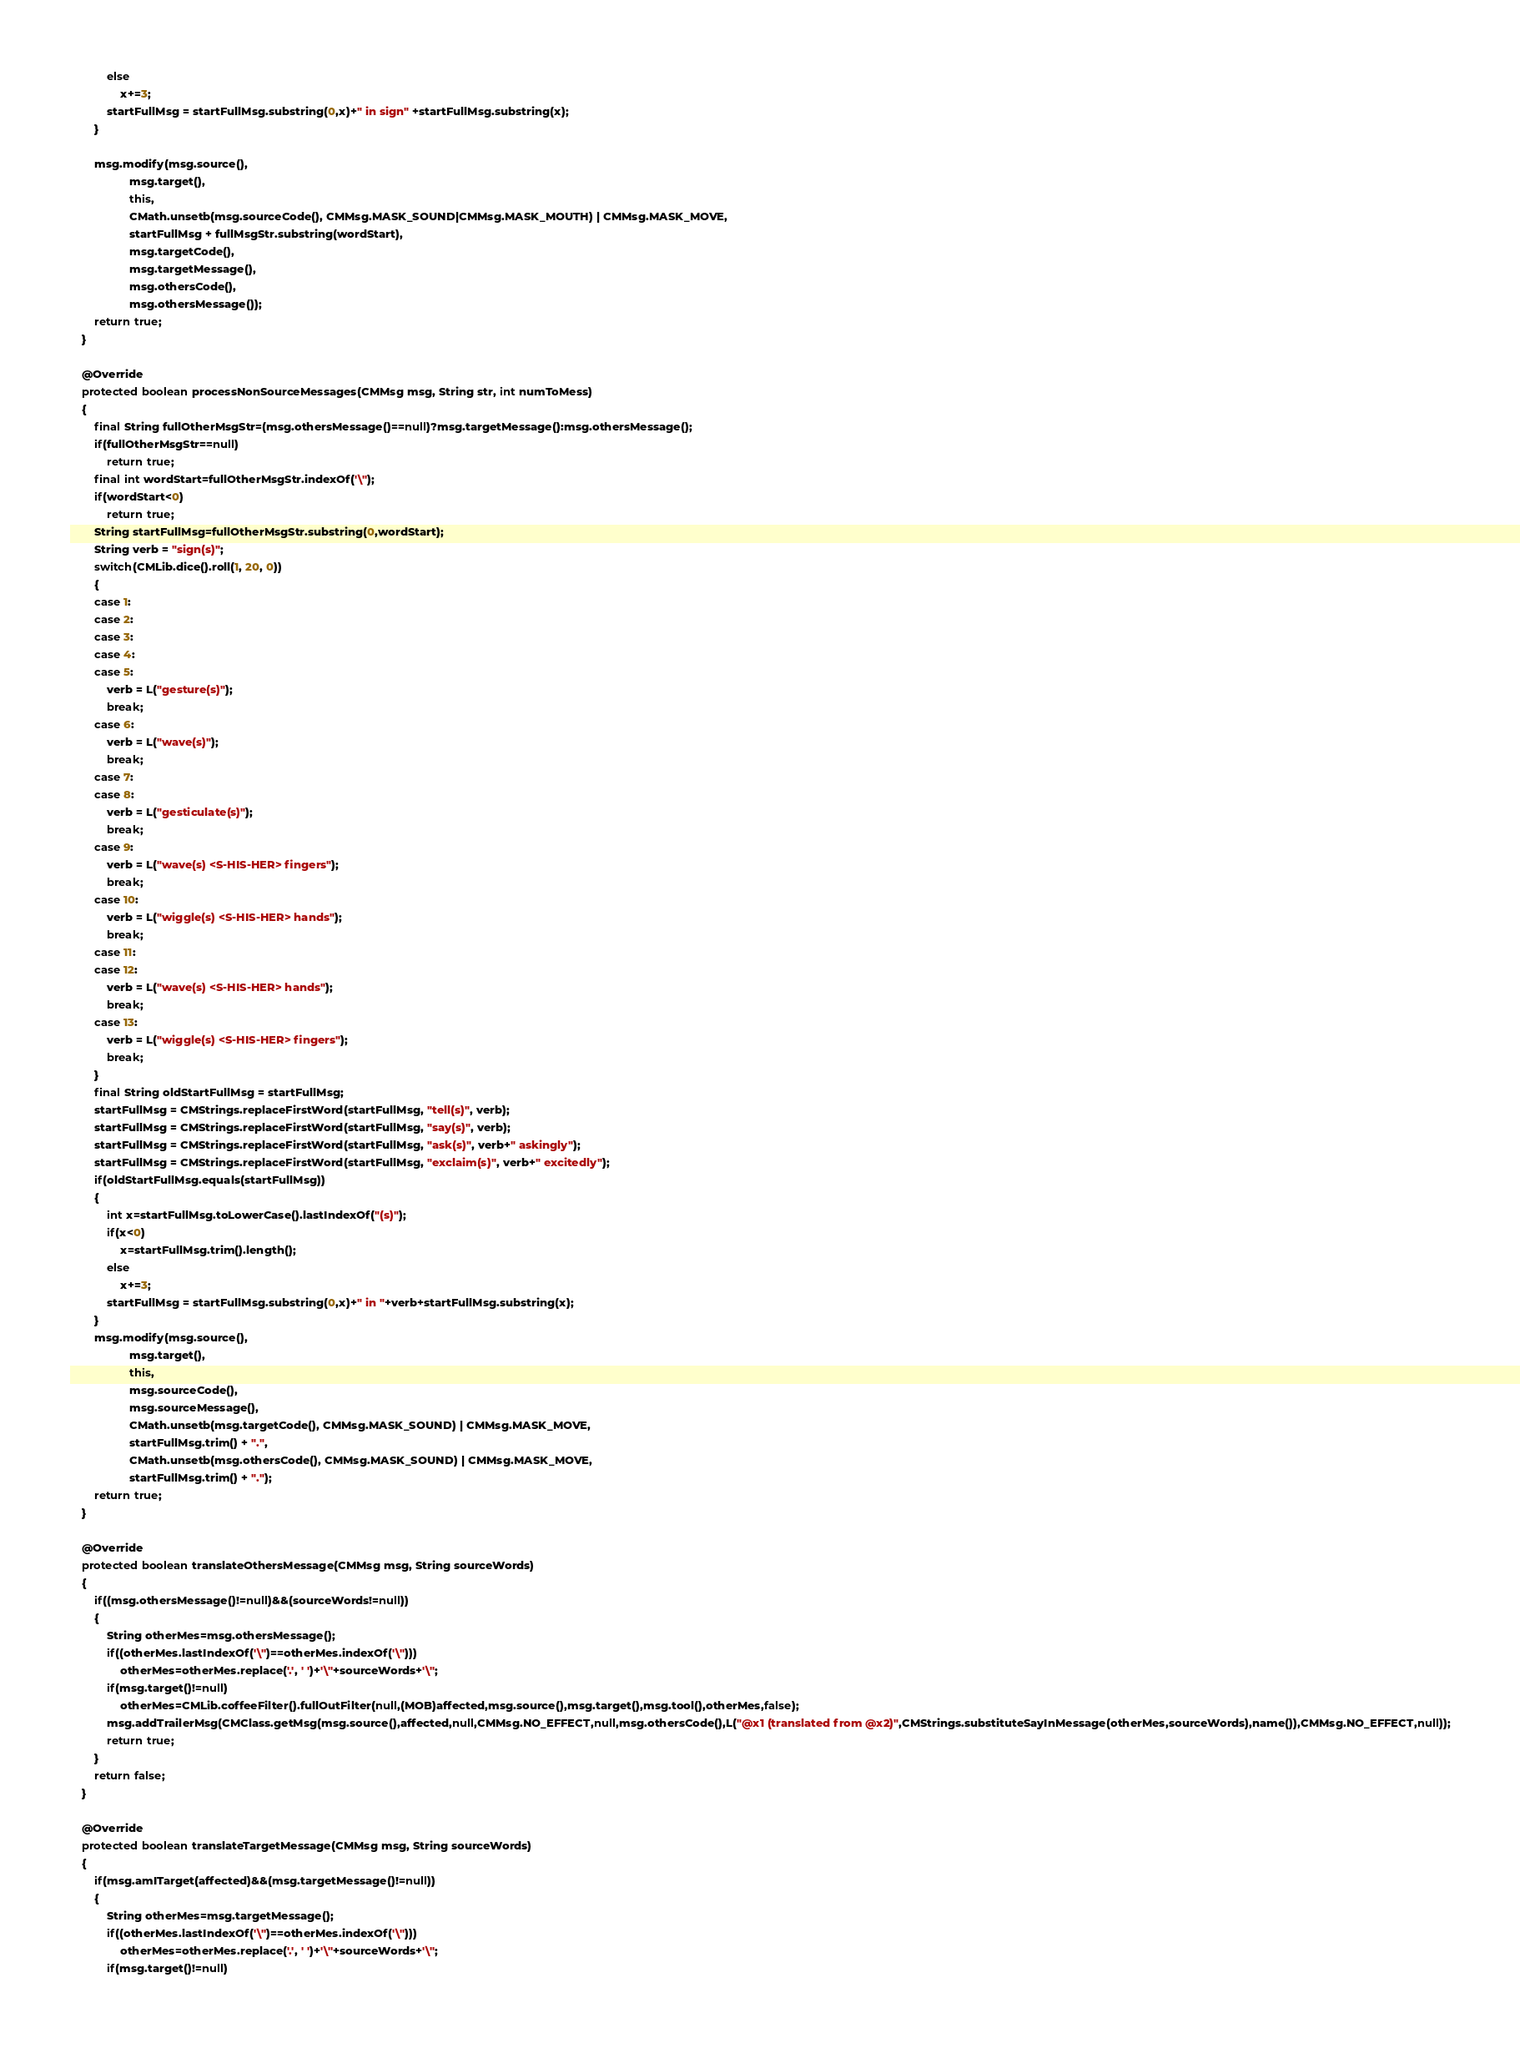<code> <loc_0><loc_0><loc_500><loc_500><_Java_>			else
				x+=3;
			startFullMsg = startFullMsg.substring(0,x)+" in sign" +startFullMsg.substring(x);
		}

		msg.modify(msg.source(),
				   msg.target(),
				   this,
				   CMath.unsetb(msg.sourceCode(), CMMsg.MASK_SOUND|CMMsg.MASK_MOUTH) | CMMsg.MASK_MOVE,
				   startFullMsg + fullMsgStr.substring(wordStart),
				   msg.targetCode(),
				   msg.targetMessage(),
				   msg.othersCode(),
				   msg.othersMessage());
		return true;
	}

	@Override
	protected boolean processNonSourceMessages(CMMsg msg, String str, int numToMess)
	{
		final String fullOtherMsgStr=(msg.othersMessage()==null)?msg.targetMessage():msg.othersMessage();
		if(fullOtherMsgStr==null)
			return true;
		final int wordStart=fullOtherMsgStr.indexOf('\'');
		if(wordStart<0)
			return true;
		String startFullMsg=fullOtherMsgStr.substring(0,wordStart);
		String verb = "sign(s)";
		switch(CMLib.dice().roll(1, 20, 0))
		{
		case 1:
		case 2:
		case 3:
		case 4:
		case 5:
			verb = L("gesture(s)");
			break;
		case 6:
			verb = L("wave(s)");
			break;
		case 7:
		case 8:
			verb = L("gesticulate(s)");
			break;
		case 9:
			verb = L("wave(s) <S-HIS-HER> fingers");
			break;
		case 10:
			verb = L("wiggle(s) <S-HIS-HER> hands");
			break;
		case 11:
		case 12:
			verb = L("wave(s) <S-HIS-HER> hands");
			break;
		case 13:
			verb = L("wiggle(s) <S-HIS-HER> fingers");
			break;
		}
		final String oldStartFullMsg = startFullMsg;
		startFullMsg = CMStrings.replaceFirstWord(startFullMsg, "tell(s)", verb);
		startFullMsg = CMStrings.replaceFirstWord(startFullMsg, "say(s)", verb);
		startFullMsg = CMStrings.replaceFirstWord(startFullMsg, "ask(s)", verb+" askingly");
		startFullMsg = CMStrings.replaceFirstWord(startFullMsg, "exclaim(s)", verb+" excitedly");
		if(oldStartFullMsg.equals(startFullMsg))
		{
			int x=startFullMsg.toLowerCase().lastIndexOf("(s)");
			if(x<0)
				x=startFullMsg.trim().length();
			else
				x+=3;
			startFullMsg = startFullMsg.substring(0,x)+" in "+verb+startFullMsg.substring(x);
		}
		msg.modify(msg.source(),
				   msg.target(),
				   this,
				   msg.sourceCode(),
				   msg.sourceMessage(),
				   CMath.unsetb(msg.targetCode(), CMMsg.MASK_SOUND) | CMMsg.MASK_MOVE,
				   startFullMsg.trim() + ".",
				   CMath.unsetb(msg.othersCode(), CMMsg.MASK_SOUND) | CMMsg.MASK_MOVE,
				   startFullMsg.trim() + ".");
		return true;
	}

	@Override
	protected boolean translateOthersMessage(CMMsg msg, String sourceWords)
	{
		if((msg.othersMessage()!=null)&&(sourceWords!=null))
		{
			String otherMes=msg.othersMessage();
			if((otherMes.lastIndexOf('\'')==otherMes.indexOf('\'')))
				otherMes=otherMes.replace('.', ' ')+'\''+sourceWords+'\'';
			if(msg.target()!=null)
				otherMes=CMLib.coffeeFilter().fullOutFilter(null,(MOB)affected,msg.source(),msg.target(),msg.tool(),otherMes,false);
			msg.addTrailerMsg(CMClass.getMsg(msg.source(),affected,null,CMMsg.NO_EFFECT,null,msg.othersCode(),L("@x1 (translated from @x2)",CMStrings.substituteSayInMessage(otherMes,sourceWords),name()),CMMsg.NO_EFFECT,null));
			return true;
		}
		return false;
	}

	@Override
	protected boolean translateTargetMessage(CMMsg msg, String sourceWords)
	{
		if(msg.amITarget(affected)&&(msg.targetMessage()!=null))
		{
			String otherMes=msg.targetMessage();
			if((otherMes.lastIndexOf('\'')==otherMes.indexOf('\'')))
				otherMes=otherMes.replace('.', ' ')+'\''+sourceWords+'\'';
			if(msg.target()!=null)</code> 